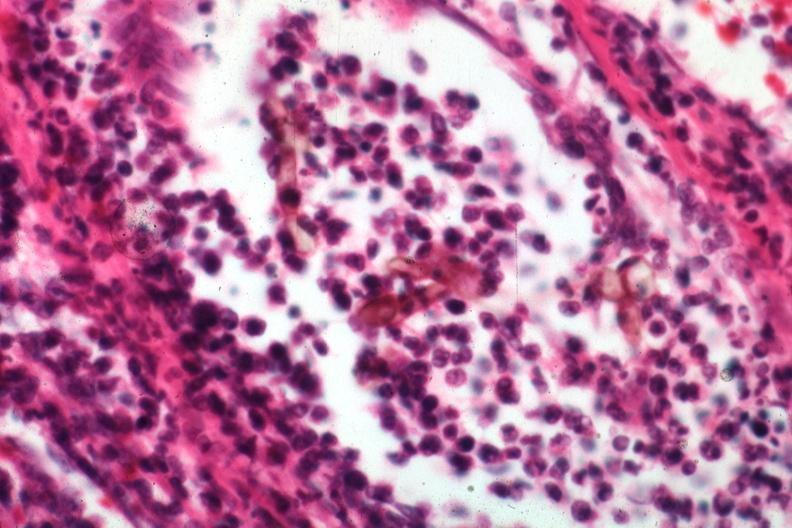where is this?
Answer the question using a single word or phrase. Skin 